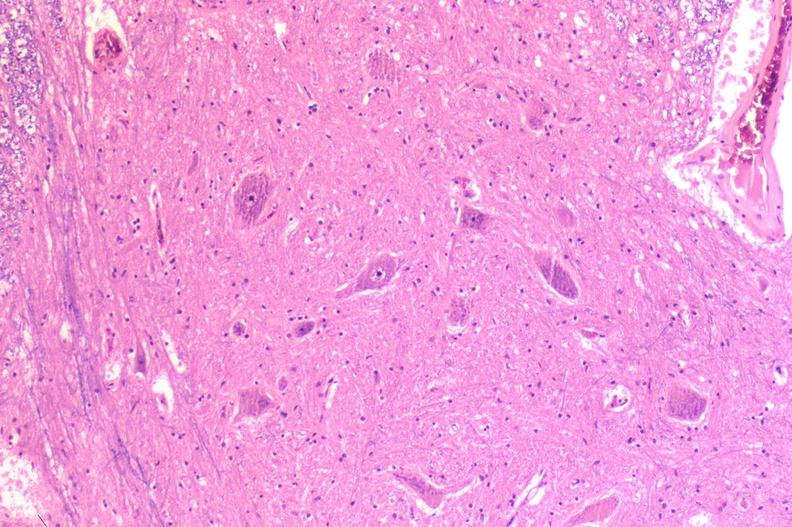what does this image show?
Answer the question using a single word or phrase. Spinal cord injury due to vertebral column trauma 